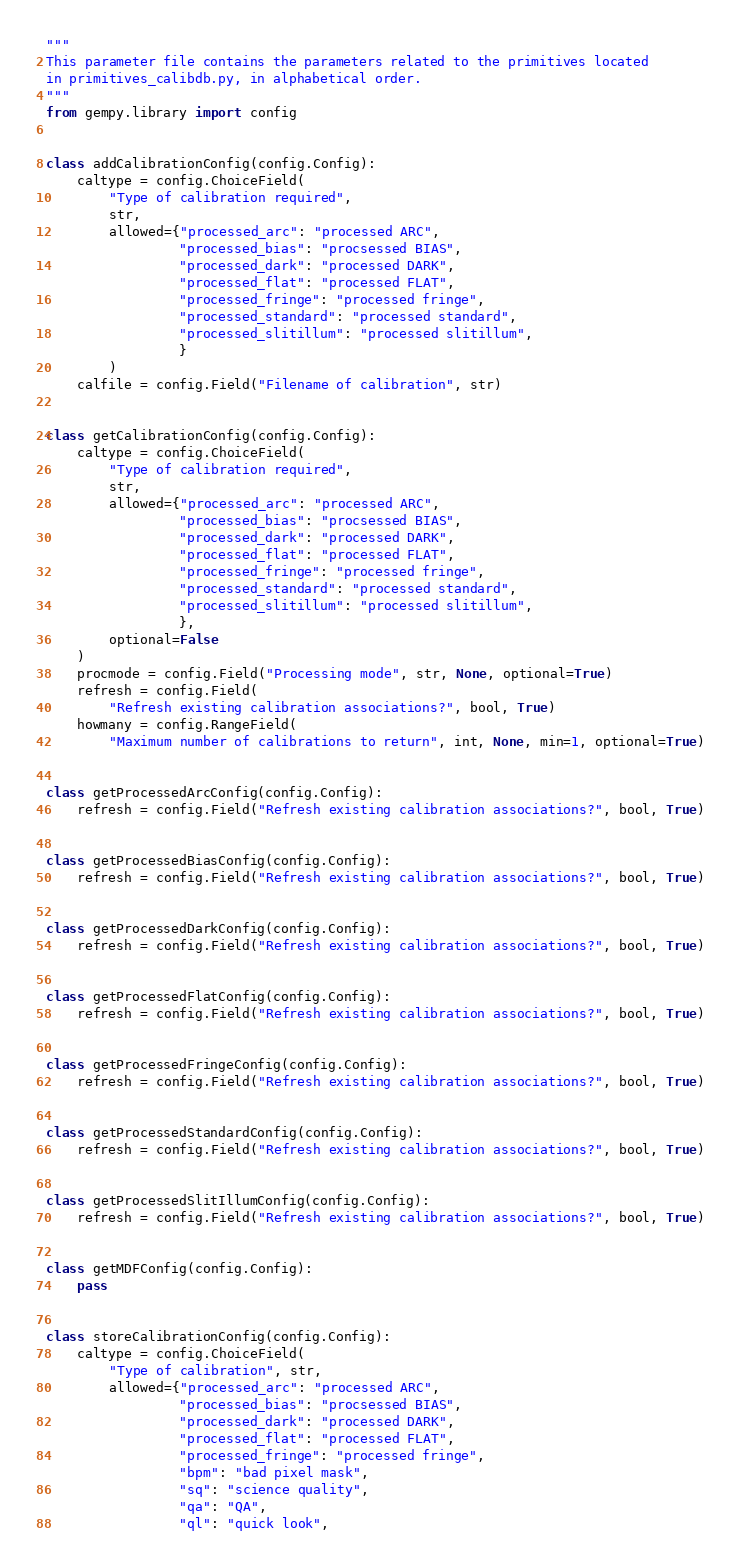Convert code to text. <code><loc_0><loc_0><loc_500><loc_500><_Python_>"""
This parameter file contains the parameters related to the primitives located
in primitives_calibdb.py, in alphabetical order.
"""
from gempy.library import config


class addCalibrationConfig(config.Config):
    caltype = config.ChoiceField(
        "Type of calibration required",
        str,
        allowed={"processed_arc": "processed ARC",
                 "processed_bias": "procsessed BIAS",
                 "processed_dark": "processed DARK",
                 "processed_flat": "processed FLAT",
                 "processed_fringe": "processed fringe",
                 "processed_standard": "processed standard",
                 "processed_slitillum": "processed slitillum",
                 }
        )
    calfile = config.Field("Filename of calibration", str)


class getCalibrationConfig(config.Config):
    caltype = config.ChoiceField(
        "Type of calibration required",
        str,
        allowed={"processed_arc": "processed ARC",
                 "processed_bias": "procsessed BIAS",
                 "processed_dark": "processed DARK",
                 "processed_flat": "processed FLAT",
                 "processed_fringe": "processed fringe",
                 "processed_standard": "processed standard",
                 "processed_slitillum": "processed slitillum",
                 },
        optional=False
    )
    procmode = config.Field("Processing mode", str, None, optional=True)
    refresh = config.Field(
        "Refresh existing calibration associations?", bool, True)
    howmany = config.RangeField(
        "Maximum number of calibrations to return", int, None, min=1, optional=True)


class getProcessedArcConfig(config.Config):
    refresh = config.Field("Refresh existing calibration associations?", bool, True)


class getProcessedBiasConfig(config.Config):
    refresh = config.Field("Refresh existing calibration associations?", bool, True)


class getProcessedDarkConfig(config.Config):
    refresh = config.Field("Refresh existing calibration associations?", bool, True)


class getProcessedFlatConfig(config.Config):
    refresh = config.Field("Refresh existing calibration associations?", bool, True)


class getProcessedFringeConfig(config.Config):
    refresh = config.Field("Refresh existing calibration associations?", bool, True)


class getProcessedStandardConfig(config.Config):
    refresh = config.Field("Refresh existing calibration associations?", bool, True)


class getProcessedSlitIllumConfig(config.Config):
    refresh = config.Field("Refresh existing calibration associations?", bool, True)


class getMDFConfig(config.Config):
    pass


class storeCalibrationConfig(config.Config):
    caltype = config.ChoiceField(
        "Type of calibration", str,
        allowed={"processed_arc": "processed ARC",
                 "processed_bias": "procsessed BIAS",
                 "processed_dark": "processed DARK",
                 "processed_flat": "processed FLAT",
                 "processed_fringe": "processed fringe",
                 "bpm": "bad pixel mask",
                 "sq": "science quality",
                 "qa": "QA",
                 "ql": "quick look",</code> 